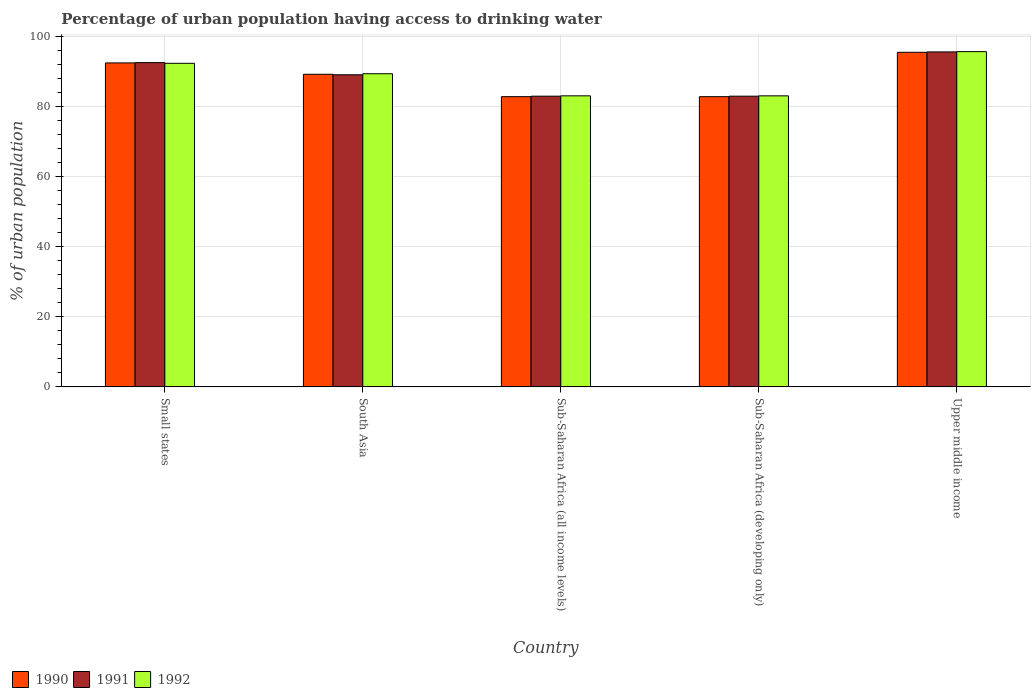What is the label of the 3rd group of bars from the left?
Offer a terse response. Sub-Saharan Africa (all income levels). In how many cases, is the number of bars for a given country not equal to the number of legend labels?
Offer a very short reply. 0. What is the percentage of urban population having access to drinking water in 1991 in Small states?
Your answer should be very brief. 92.62. Across all countries, what is the maximum percentage of urban population having access to drinking water in 1992?
Provide a succinct answer. 95.76. Across all countries, what is the minimum percentage of urban population having access to drinking water in 1991?
Ensure brevity in your answer.  83.04. In which country was the percentage of urban population having access to drinking water in 1990 maximum?
Provide a short and direct response. Upper middle income. In which country was the percentage of urban population having access to drinking water in 1990 minimum?
Provide a short and direct response. Sub-Saharan Africa (developing only). What is the total percentage of urban population having access to drinking water in 1992 in the graph?
Give a very brief answer. 443.9. What is the difference between the percentage of urban population having access to drinking water in 1992 in South Asia and that in Sub-Saharan Africa (developing only)?
Ensure brevity in your answer.  6.32. What is the difference between the percentage of urban population having access to drinking water in 1990 in Upper middle income and the percentage of urban population having access to drinking water in 1992 in Sub-Saharan Africa (all income levels)?
Ensure brevity in your answer.  12.44. What is the average percentage of urban population having access to drinking water in 1992 per country?
Your answer should be compact. 88.78. What is the difference between the percentage of urban population having access to drinking water of/in 1990 and percentage of urban population having access to drinking water of/in 1992 in South Asia?
Your answer should be compact. -0.15. In how many countries, is the percentage of urban population having access to drinking water in 1990 greater than 88 %?
Keep it short and to the point. 3. What is the ratio of the percentage of urban population having access to drinking water in 1990 in Small states to that in South Asia?
Your answer should be compact. 1.04. Is the difference between the percentage of urban population having access to drinking water in 1990 in Small states and South Asia greater than the difference between the percentage of urban population having access to drinking water in 1992 in Small states and South Asia?
Keep it short and to the point. Yes. What is the difference between the highest and the second highest percentage of urban population having access to drinking water in 1992?
Offer a very short reply. -2.98. What is the difference between the highest and the lowest percentage of urban population having access to drinking water in 1991?
Provide a succinct answer. 12.65. In how many countries, is the percentage of urban population having access to drinking water in 1990 greater than the average percentage of urban population having access to drinking water in 1990 taken over all countries?
Ensure brevity in your answer.  3. Is the sum of the percentage of urban population having access to drinking water in 1992 in Small states and Sub-Saharan Africa (all income levels) greater than the maximum percentage of urban population having access to drinking water in 1991 across all countries?
Your response must be concise. Yes. What does the 1st bar from the right in Small states represents?
Provide a short and direct response. 1992. Is it the case that in every country, the sum of the percentage of urban population having access to drinking water in 1990 and percentage of urban population having access to drinking water in 1992 is greater than the percentage of urban population having access to drinking water in 1991?
Your answer should be very brief. Yes. Are all the bars in the graph horizontal?
Your response must be concise. No. What is the difference between two consecutive major ticks on the Y-axis?
Ensure brevity in your answer.  20. Are the values on the major ticks of Y-axis written in scientific E-notation?
Give a very brief answer. No. What is the title of the graph?
Your response must be concise. Percentage of urban population having access to drinking water. What is the label or title of the X-axis?
Ensure brevity in your answer.  Country. What is the label or title of the Y-axis?
Provide a succinct answer. % of urban population. What is the % of urban population in 1990 in Small states?
Ensure brevity in your answer.  92.54. What is the % of urban population in 1991 in Small states?
Make the answer very short. 92.62. What is the % of urban population of 1992 in Small states?
Provide a short and direct response. 92.43. What is the % of urban population in 1990 in South Asia?
Provide a succinct answer. 89.29. What is the % of urban population in 1991 in South Asia?
Keep it short and to the point. 89.15. What is the % of urban population of 1992 in South Asia?
Keep it short and to the point. 89.45. What is the % of urban population of 1990 in Sub-Saharan Africa (all income levels)?
Give a very brief answer. 82.9. What is the % of urban population in 1991 in Sub-Saharan Africa (all income levels)?
Make the answer very short. 83.04. What is the % of urban population in 1992 in Sub-Saharan Africa (all income levels)?
Give a very brief answer. 83.13. What is the % of urban population in 1990 in Sub-Saharan Africa (developing only)?
Keep it short and to the point. 82.9. What is the % of urban population in 1991 in Sub-Saharan Africa (developing only)?
Provide a succinct answer. 83.04. What is the % of urban population of 1992 in Sub-Saharan Africa (developing only)?
Offer a terse response. 83.13. What is the % of urban population in 1990 in Upper middle income?
Offer a terse response. 95.57. What is the % of urban population of 1991 in Upper middle income?
Your answer should be very brief. 95.68. What is the % of urban population in 1992 in Upper middle income?
Your answer should be compact. 95.76. Across all countries, what is the maximum % of urban population in 1990?
Keep it short and to the point. 95.57. Across all countries, what is the maximum % of urban population of 1991?
Make the answer very short. 95.68. Across all countries, what is the maximum % of urban population of 1992?
Your answer should be very brief. 95.76. Across all countries, what is the minimum % of urban population in 1990?
Your answer should be very brief. 82.9. Across all countries, what is the minimum % of urban population of 1991?
Provide a succinct answer. 83.04. Across all countries, what is the minimum % of urban population of 1992?
Ensure brevity in your answer.  83.13. What is the total % of urban population in 1990 in the graph?
Offer a very short reply. 443.2. What is the total % of urban population in 1991 in the graph?
Keep it short and to the point. 443.54. What is the total % of urban population of 1992 in the graph?
Offer a terse response. 443.9. What is the difference between the % of urban population of 1990 in Small states and that in South Asia?
Provide a short and direct response. 3.25. What is the difference between the % of urban population in 1991 in Small states and that in South Asia?
Give a very brief answer. 3.47. What is the difference between the % of urban population of 1992 in Small states and that in South Asia?
Provide a short and direct response. 2.98. What is the difference between the % of urban population of 1990 in Small states and that in Sub-Saharan Africa (all income levels)?
Offer a terse response. 9.64. What is the difference between the % of urban population of 1991 in Small states and that in Sub-Saharan Africa (all income levels)?
Make the answer very short. 9.58. What is the difference between the % of urban population of 1992 in Small states and that in Sub-Saharan Africa (all income levels)?
Offer a terse response. 9.29. What is the difference between the % of urban population of 1990 in Small states and that in Sub-Saharan Africa (developing only)?
Your answer should be very brief. 9.64. What is the difference between the % of urban population in 1991 in Small states and that in Sub-Saharan Africa (developing only)?
Make the answer very short. 9.59. What is the difference between the % of urban population of 1992 in Small states and that in Sub-Saharan Africa (developing only)?
Ensure brevity in your answer.  9.3. What is the difference between the % of urban population of 1990 in Small states and that in Upper middle income?
Your answer should be compact. -3.03. What is the difference between the % of urban population of 1991 in Small states and that in Upper middle income?
Offer a terse response. -3.06. What is the difference between the % of urban population in 1992 in Small states and that in Upper middle income?
Provide a succinct answer. -3.33. What is the difference between the % of urban population in 1990 in South Asia and that in Sub-Saharan Africa (all income levels)?
Provide a succinct answer. 6.39. What is the difference between the % of urban population of 1991 in South Asia and that in Sub-Saharan Africa (all income levels)?
Keep it short and to the point. 6.11. What is the difference between the % of urban population in 1992 in South Asia and that in Sub-Saharan Africa (all income levels)?
Offer a terse response. 6.31. What is the difference between the % of urban population in 1990 in South Asia and that in Sub-Saharan Africa (developing only)?
Make the answer very short. 6.4. What is the difference between the % of urban population in 1991 in South Asia and that in Sub-Saharan Africa (developing only)?
Offer a very short reply. 6.12. What is the difference between the % of urban population of 1992 in South Asia and that in Sub-Saharan Africa (developing only)?
Provide a short and direct response. 6.32. What is the difference between the % of urban population in 1990 in South Asia and that in Upper middle income?
Your response must be concise. -6.28. What is the difference between the % of urban population of 1991 in South Asia and that in Upper middle income?
Give a very brief answer. -6.53. What is the difference between the % of urban population in 1992 in South Asia and that in Upper middle income?
Ensure brevity in your answer.  -6.31. What is the difference between the % of urban population of 1990 in Sub-Saharan Africa (all income levels) and that in Sub-Saharan Africa (developing only)?
Ensure brevity in your answer.  0. What is the difference between the % of urban population in 1991 in Sub-Saharan Africa (all income levels) and that in Sub-Saharan Africa (developing only)?
Your answer should be compact. 0. What is the difference between the % of urban population in 1992 in Sub-Saharan Africa (all income levels) and that in Sub-Saharan Africa (developing only)?
Your response must be concise. 0. What is the difference between the % of urban population in 1990 in Sub-Saharan Africa (all income levels) and that in Upper middle income?
Offer a terse response. -12.67. What is the difference between the % of urban population in 1991 in Sub-Saharan Africa (all income levels) and that in Upper middle income?
Offer a terse response. -12.64. What is the difference between the % of urban population of 1992 in Sub-Saharan Africa (all income levels) and that in Upper middle income?
Provide a succinct answer. -12.63. What is the difference between the % of urban population in 1990 in Sub-Saharan Africa (developing only) and that in Upper middle income?
Keep it short and to the point. -12.67. What is the difference between the % of urban population in 1991 in Sub-Saharan Africa (developing only) and that in Upper middle income?
Offer a terse response. -12.65. What is the difference between the % of urban population in 1992 in Sub-Saharan Africa (developing only) and that in Upper middle income?
Provide a succinct answer. -12.63. What is the difference between the % of urban population in 1990 in Small states and the % of urban population in 1991 in South Asia?
Give a very brief answer. 3.38. What is the difference between the % of urban population in 1990 in Small states and the % of urban population in 1992 in South Asia?
Your answer should be compact. 3.09. What is the difference between the % of urban population in 1991 in Small states and the % of urban population in 1992 in South Asia?
Ensure brevity in your answer.  3.18. What is the difference between the % of urban population of 1990 in Small states and the % of urban population of 1991 in Sub-Saharan Africa (all income levels)?
Ensure brevity in your answer.  9.5. What is the difference between the % of urban population of 1990 in Small states and the % of urban population of 1992 in Sub-Saharan Africa (all income levels)?
Your answer should be compact. 9.4. What is the difference between the % of urban population of 1991 in Small states and the % of urban population of 1992 in Sub-Saharan Africa (all income levels)?
Offer a very short reply. 9.49. What is the difference between the % of urban population in 1990 in Small states and the % of urban population in 1991 in Sub-Saharan Africa (developing only)?
Keep it short and to the point. 9.5. What is the difference between the % of urban population of 1990 in Small states and the % of urban population of 1992 in Sub-Saharan Africa (developing only)?
Your answer should be very brief. 9.41. What is the difference between the % of urban population of 1991 in Small states and the % of urban population of 1992 in Sub-Saharan Africa (developing only)?
Provide a short and direct response. 9.49. What is the difference between the % of urban population of 1990 in Small states and the % of urban population of 1991 in Upper middle income?
Offer a terse response. -3.14. What is the difference between the % of urban population of 1990 in Small states and the % of urban population of 1992 in Upper middle income?
Your response must be concise. -3.22. What is the difference between the % of urban population of 1991 in Small states and the % of urban population of 1992 in Upper middle income?
Provide a short and direct response. -3.14. What is the difference between the % of urban population in 1990 in South Asia and the % of urban population in 1991 in Sub-Saharan Africa (all income levels)?
Provide a succinct answer. 6.25. What is the difference between the % of urban population in 1990 in South Asia and the % of urban population in 1992 in Sub-Saharan Africa (all income levels)?
Provide a succinct answer. 6.16. What is the difference between the % of urban population in 1991 in South Asia and the % of urban population in 1992 in Sub-Saharan Africa (all income levels)?
Keep it short and to the point. 6.02. What is the difference between the % of urban population in 1990 in South Asia and the % of urban population in 1991 in Sub-Saharan Africa (developing only)?
Keep it short and to the point. 6.26. What is the difference between the % of urban population of 1990 in South Asia and the % of urban population of 1992 in Sub-Saharan Africa (developing only)?
Keep it short and to the point. 6.16. What is the difference between the % of urban population of 1991 in South Asia and the % of urban population of 1992 in Sub-Saharan Africa (developing only)?
Offer a very short reply. 6.02. What is the difference between the % of urban population of 1990 in South Asia and the % of urban population of 1991 in Upper middle income?
Give a very brief answer. -6.39. What is the difference between the % of urban population of 1990 in South Asia and the % of urban population of 1992 in Upper middle income?
Give a very brief answer. -6.47. What is the difference between the % of urban population of 1991 in South Asia and the % of urban population of 1992 in Upper middle income?
Provide a succinct answer. -6.61. What is the difference between the % of urban population in 1990 in Sub-Saharan Africa (all income levels) and the % of urban population in 1991 in Sub-Saharan Africa (developing only)?
Keep it short and to the point. -0.14. What is the difference between the % of urban population in 1990 in Sub-Saharan Africa (all income levels) and the % of urban population in 1992 in Sub-Saharan Africa (developing only)?
Offer a terse response. -0.23. What is the difference between the % of urban population in 1991 in Sub-Saharan Africa (all income levels) and the % of urban population in 1992 in Sub-Saharan Africa (developing only)?
Your answer should be very brief. -0.09. What is the difference between the % of urban population of 1990 in Sub-Saharan Africa (all income levels) and the % of urban population of 1991 in Upper middle income?
Keep it short and to the point. -12.78. What is the difference between the % of urban population of 1990 in Sub-Saharan Africa (all income levels) and the % of urban population of 1992 in Upper middle income?
Provide a short and direct response. -12.86. What is the difference between the % of urban population of 1991 in Sub-Saharan Africa (all income levels) and the % of urban population of 1992 in Upper middle income?
Provide a succinct answer. -12.72. What is the difference between the % of urban population in 1990 in Sub-Saharan Africa (developing only) and the % of urban population in 1991 in Upper middle income?
Your answer should be very brief. -12.79. What is the difference between the % of urban population of 1990 in Sub-Saharan Africa (developing only) and the % of urban population of 1992 in Upper middle income?
Your answer should be very brief. -12.86. What is the difference between the % of urban population of 1991 in Sub-Saharan Africa (developing only) and the % of urban population of 1992 in Upper middle income?
Offer a very short reply. -12.73. What is the average % of urban population of 1990 per country?
Make the answer very short. 88.64. What is the average % of urban population in 1991 per country?
Keep it short and to the point. 88.71. What is the average % of urban population in 1992 per country?
Your answer should be very brief. 88.78. What is the difference between the % of urban population of 1990 and % of urban population of 1991 in Small states?
Your response must be concise. -0.08. What is the difference between the % of urban population in 1990 and % of urban population in 1992 in Small states?
Keep it short and to the point. 0.11. What is the difference between the % of urban population in 1991 and % of urban population in 1992 in Small states?
Ensure brevity in your answer.  0.19. What is the difference between the % of urban population of 1990 and % of urban population of 1991 in South Asia?
Provide a short and direct response. 0.14. What is the difference between the % of urban population of 1990 and % of urban population of 1992 in South Asia?
Your answer should be compact. -0.15. What is the difference between the % of urban population of 1991 and % of urban population of 1992 in South Asia?
Provide a succinct answer. -0.29. What is the difference between the % of urban population of 1990 and % of urban population of 1991 in Sub-Saharan Africa (all income levels)?
Provide a succinct answer. -0.14. What is the difference between the % of urban population of 1990 and % of urban population of 1992 in Sub-Saharan Africa (all income levels)?
Provide a succinct answer. -0.23. What is the difference between the % of urban population of 1991 and % of urban population of 1992 in Sub-Saharan Africa (all income levels)?
Provide a short and direct response. -0.1. What is the difference between the % of urban population of 1990 and % of urban population of 1991 in Sub-Saharan Africa (developing only)?
Provide a short and direct response. -0.14. What is the difference between the % of urban population in 1990 and % of urban population in 1992 in Sub-Saharan Africa (developing only)?
Your answer should be compact. -0.23. What is the difference between the % of urban population of 1991 and % of urban population of 1992 in Sub-Saharan Africa (developing only)?
Ensure brevity in your answer.  -0.1. What is the difference between the % of urban population in 1990 and % of urban population in 1991 in Upper middle income?
Your answer should be very brief. -0.11. What is the difference between the % of urban population of 1990 and % of urban population of 1992 in Upper middle income?
Your answer should be compact. -0.19. What is the difference between the % of urban population of 1991 and % of urban population of 1992 in Upper middle income?
Your answer should be very brief. -0.08. What is the ratio of the % of urban population of 1990 in Small states to that in South Asia?
Give a very brief answer. 1.04. What is the ratio of the % of urban population in 1991 in Small states to that in South Asia?
Offer a very short reply. 1.04. What is the ratio of the % of urban population in 1992 in Small states to that in South Asia?
Provide a succinct answer. 1.03. What is the ratio of the % of urban population of 1990 in Small states to that in Sub-Saharan Africa (all income levels)?
Provide a succinct answer. 1.12. What is the ratio of the % of urban population of 1991 in Small states to that in Sub-Saharan Africa (all income levels)?
Provide a short and direct response. 1.12. What is the ratio of the % of urban population in 1992 in Small states to that in Sub-Saharan Africa (all income levels)?
Ensure brevity in your answer.  1.11. What is the ratio of the % of urban population of 1990 in Small states to that in Sub-Saharan Africa (developing only)?
Ensure brevity in your answer.  1.12. What is the ratio of the % of urban population of 1991 in Small states to that in Sub-Saharan Africa (developing only)?
Your answer should be very brief. 1.12. What is the ratio of the % of urban population in 1992 in Small states to that in Sub-Saharan Africa (developing only)?
Your answer should be very brief. 1.11. What is the ratio of the % of urban population of 1990 in Small states to that in Upper middle income?
Give a very brief answer. 0.97. What is the ratio of the % of urban population of 1991 in Small states to that in Upper middle income?
Give a very brief answer. 0.97. What is the ratio of the % of urban population in 1992 in Small states to that in Upper middle income?
Your answer should be very brief. 0.97. What is the ratio of the % of urban population of 1990 in South Asia to that in Sub-Saharan Africa (all income levels)?
Ensure brevity in your answer.  1.08. What is the ratio of the % of urban population of 1991 in South Asia to that in Sub-Saharan Africa (all income levels)?
Make the answer very short. 1.07. What is the ratio of the % of urban population in 1992 in South Asia to that in Sub-Saharan Africa (all income levels)?
Give a very brief answer. 1.08. What is the ratio of the % of urban population of 1990 in South Asia to that in Sub-Saharan Africa (developing only)?
Provide a short and direct response. 1.08. What is the ratio of the % of urban population in 1991 in South Asia to that in Sub-Saharan Africa (developing only)?
Provide a succinct answer. 1.07. What is the ratio of the % of urban population in 1992 in South Asia to that in Sub-Saharan Africa (developing only)?
Ensure brevity in your answer.  1.08. What is the ratio of the % of urban population of 1990 in South Asia to that in Upper middle income?
Ensure brevity in your answer.  0.93. What is the ratio of the % of urban population in 1991 in South Asia to that in Upper middle income?
Give a very brief answer. 0.93. What is the ratio of the % of urban population in 1992 in South Asia to that in Upper middle income?
Offer a terse response. 0.93. What is the ratio of the % of urban population in 1990 in Sub-Saharan Africa (all income levels) to that in Upper middle income?
Keep it short and to the point. 0.87. What is the ratio of the % of urban population in 1991 in Sub-Saharan Africa (all income levels) to that in Upper middle income?
Provide a succinct answer. 0.87. What is the ratio of the % of urban population of 1992 in Sub-Saharan Africa (all income levels) to that in Upper middle income?
Give a very brief answer. 0.87. What is the ratio of the % of urban population of 1990 in Sub-Saharan Africa (developing only) to that in Upper middle income?
Give a very brief answer. 0.87. What is the ratio of the % of urban population of 1991 in Sub-Saharan Africa (developing only) to that in Upper middle income?
Keep it short and to the point. 0.87. What is the ratio of the % of urban population of 1992 in Sub-Saharan Africa (developing only) to that in Upper middle income?
Give a very brief answer. 0.87. What is the difference between the highest and the second highest % of urban population in 1990?
Your answer should be very brief. 3.03. What is the difference between the highest and the second highest % of urban population of 1991?
Keep it short and to the point. 3.06. What is the difference between the highest and the second highest % of urban population of 1992?
Ensure brevity in your answer.  3.33. What is the difference between the highest and the lowest % of urban population in 1990?
Keep it short and to the point. 12.67. What is the difference between the highest and the lowest % of urban population in 1991?
Offer a terse response. 12.65. What is the difference between the highest and the lowest % of urban population of 1992?
Offer a terse response. 12.63. 